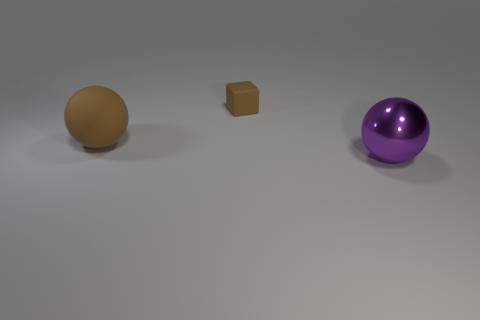Add 1 tiny rubber cylinders. How many objects exist? 4 Subtract all balls. How many objects are left? 1 Add 2 tiny blocks. How many tiny blocks are left? 3 Add 3 big brown rubber things. How many big brown rubber things exist? 4 Subtract 0 green balls. How many objects are left? 3 Subtract all purple blocks. Subtract all brown things. How many objects are left? 1 